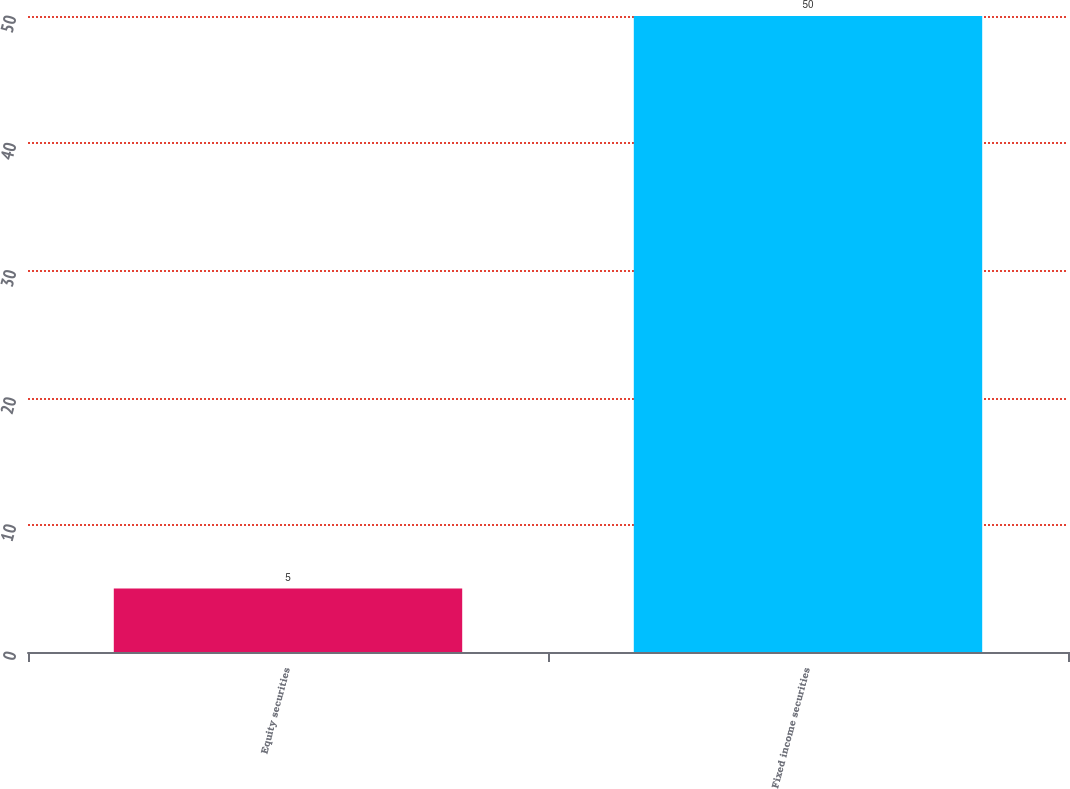<chart> <loc_0><loc_0><loc_500><loc_500><bar_chart><fcel>Equity securities<fcel>Fixed income securities<nl><fcel>5<fcel>50<nl></chart> 